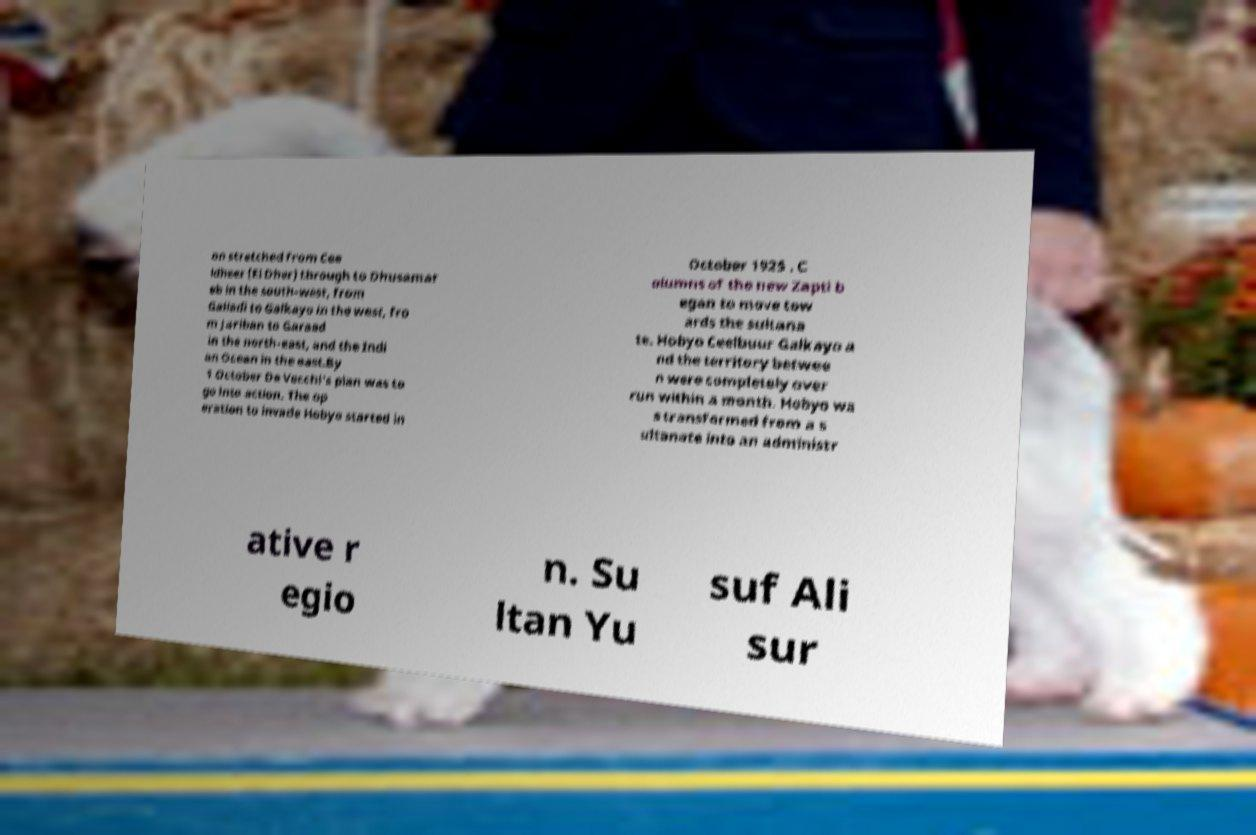Could you extract and type out the text from this image? on stretched from Cee ldheer (El Dher) through to Dhusamar eb in the south-west, from Galladi to Galkayo in the west, fro m Jariban to Garaad in the north-east, and the Indi an Ocean in the east.By 1 October De Vecchi's plan was to go into action. The op eration to invade Hobyo started in October 1925 . C olumns of the new Zapti b egan to move tow ards the sultana te. Hobyo Ceelbuur Galkayo a nd the territory betwee n were completely over run within a month. Hobyo wa s transformed from a s ultanate into an administr ative r egio n. Su ltan Yu suf Ali sur 